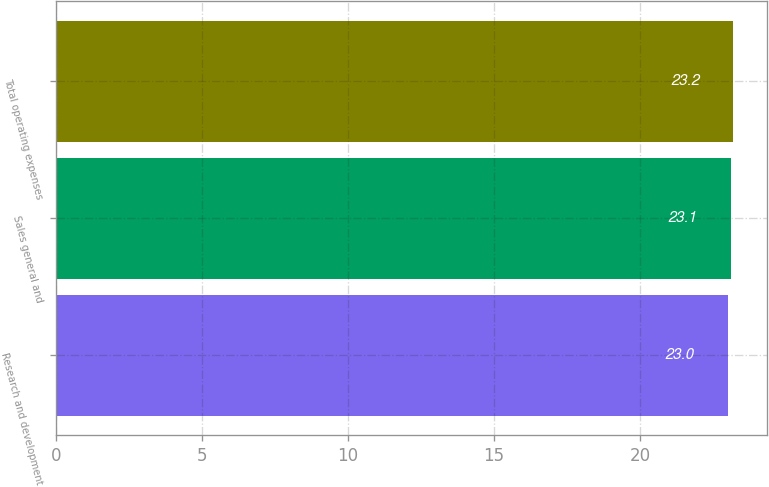Convert chart. <chart><loc_0><loc_0><loc_500><loc_500><bar_chart><fcel>Research and development<fcel>Sales general and<fcel>Total operating expenses<nl><fcel>23<fcel>23.1<fcel>23.2<nl></chart> 